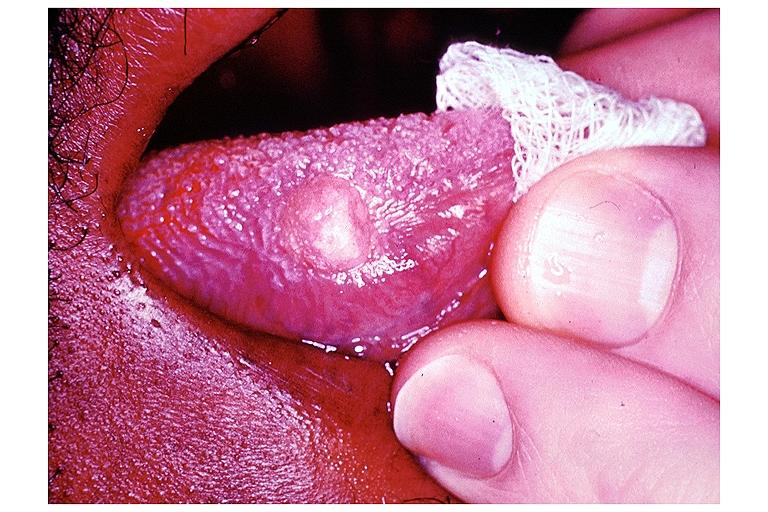what does this image show?
Answer the question using a single word or phrase. Granular cell tumor 